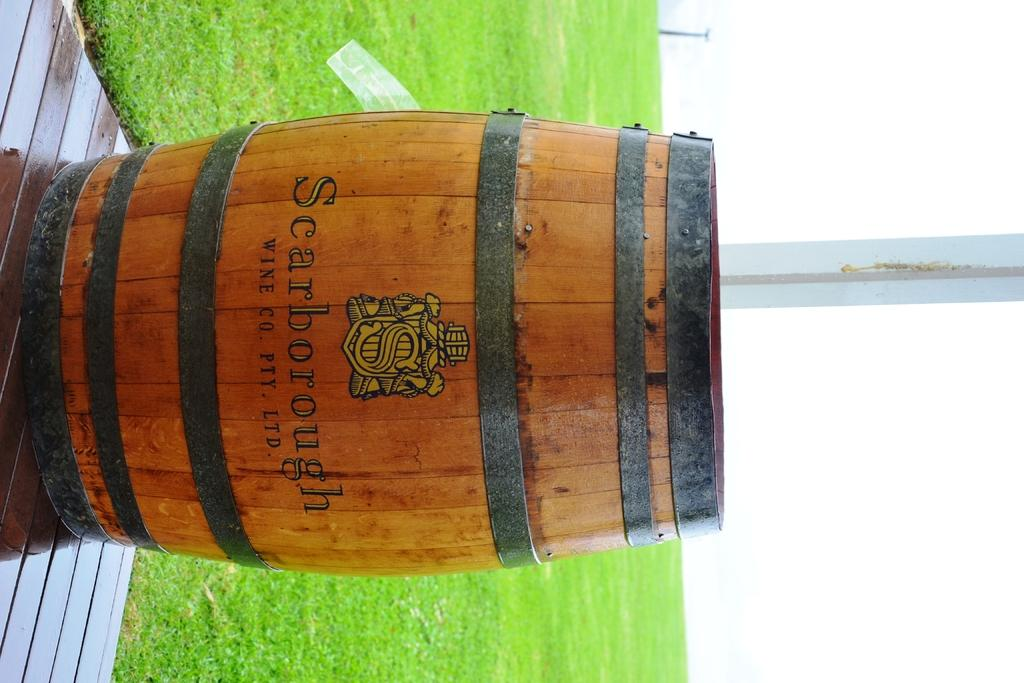What type of musical instrument is in the image? There is a wooden drum in the image. Where is the wooden drum located? The wooden drum is kept on the floor. What can be seen on the ground behind the drum? There is grass on the ground behind the drum. What is visible in the sky in the image? The sky is visible and clear in the image. What type of pan is being used to cook food in the image? There is no pan or cooking activity present in the image; it features a wooden drum on the floor. What kind of error can be seen in the image? There is no error present in the image; it is a clear image of a wooden drum on the floor with grass and a clear sky in the background. 